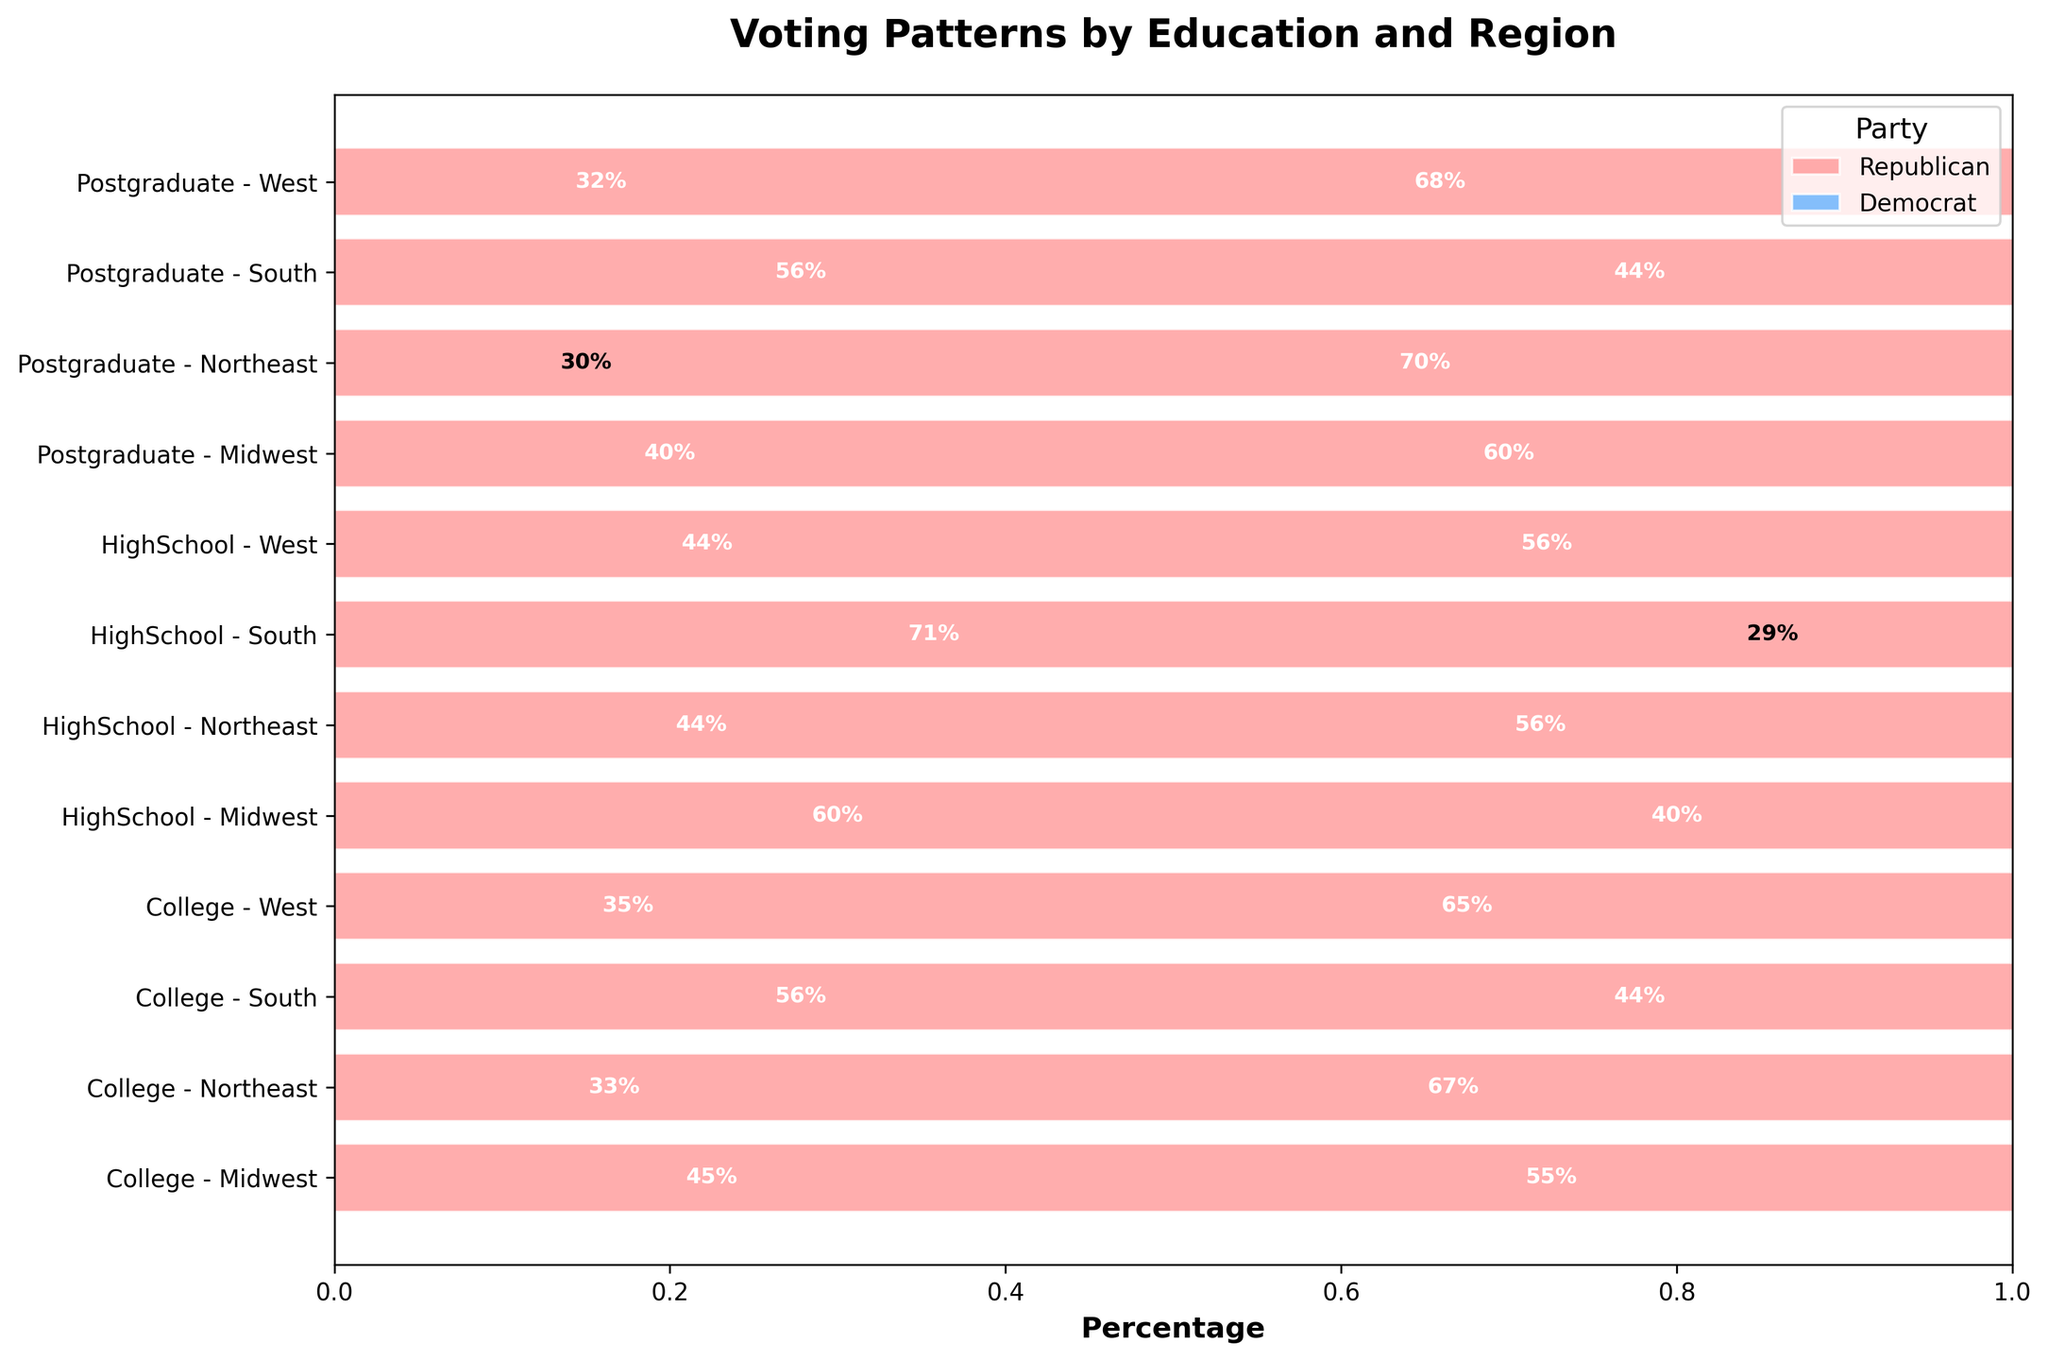What are the colors used to represent the Republican and Democrat parties in the plot? The colors used in the bars to represent the Republican and Democrat parties are distinct. The bars for the Republican party are red, while the bars for the Democrat party are blue. This distinction helps to identify the vote counts for each party.
Answer: Red for Republican, Blue for Democrat What is the title of the plot? The title is displayed at the top center of the plot and provides information on what the visual data represents. By reading the title, one can understand that the plot shows voting patterns based on education level and regional differences.
Answer: Voting Patterns by Education and Region Which education level and region combination has the highest percentage of Democrat voters? To find the highest percentage, observe the lengths of the blue bars across each combination of education level and region. The combination with the longest blue bar for Democrat voters will be the answer.
Answer: College - West How does the percentage of Republican voters with a high school education compare between the Midwest and the South? Compare the lengths of the red bars within the sections labeled 'HighSchool - Midwest' and 'HighSchool - South.' The bar length indicates the proportion of Republican voters within each region for those with a high school education.
Answer: Higher in the South What is the total count of voters with a postgraduate education in the Northeast? Sum the counts of both Republican and Democrat voters with postgraduate education in the Northeast. The plot's bar lengths and labels show individual counts for each party, which can be added together.
Answer: 300 (Republican) + 700 (Democrat) = 1000 Which region has the smallest difference in the percentage of votes between Republicans and Democrats among those with a college education? Calculate the differences in bar lengths (in percentage terms) between Republican and Democrat voters for each region with college education, and identify the smallest difference.
Answer: Midwest In which region is the percentage of Republican voters higher for high school education than for college education? Compare the red bar lengths in the 'HighSchool' and 'College' sections for each region. Look for regions where the red bar is longer in the 'HighSchool' section.
Answer: South What can be said about the voting pattern of postgraduate voters in the West? Observe the proportion of the blue and red bars in the 'Postgraduate - West' section. The section indicates the distribution between Democrat and Republican voters.
Answer: More Democrat voters How does the percentage of Democrat voters with a postgraduate education compare between the Midwest and the West? Compare the lengths of the blue bars in the 'Postgraduate - Midwest' and 'Postgraduate - West' sections. Determine which region has a longer blue bar to find the region with a higher percentage of Democrat voters.
Answer: Higher in the West 